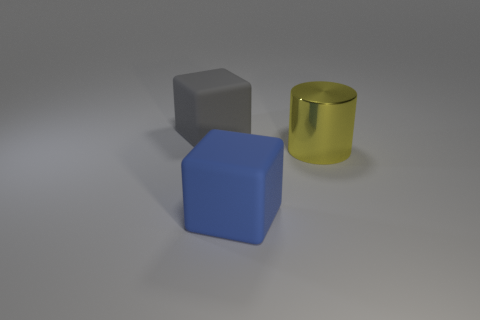Is there any other thing of the same color as the large metal object?
Offer a very short reply. No. What number of things are either matte cubes that are behind the blue cube or big yellow metal cylinders?
Give a very brief answer. 2. What is the big thing that is left of the blue thing made of?
Your response must be concise. Rubber. What is the material of the big yellow object?
Make the answer very short. Metal. What material is the big block that is behind the matte cube that is in front of the big cube that is behind the blue cube?
Ensure brevity in your answer.  Rubber. Is there anything else that has the same material as the cylinder?
Provide a succinct answer. No. Is the size of the blue block the same as the cylinder that is in front of the gray object?
Ensure brevity in your answer.  Yes. What number of things are either big rubber cubes behind the blue cube or rubber objects that are in front of the yellow shiny cylinder?
Make the answer very short. 2. There is a object that is behind the shiny thing; what color is it?
Give a very brief answer. Gray. Is there a big cylinder on the left side of the matte object that is behind the large blue rubber object?
Your answer should be compact. No. 